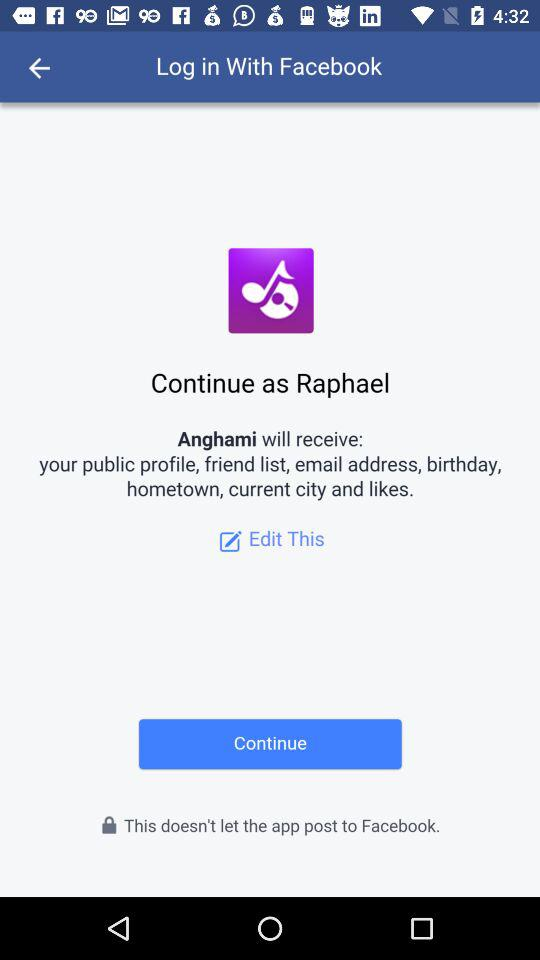What is the user name to continue the profile? The user name is Raphael. 